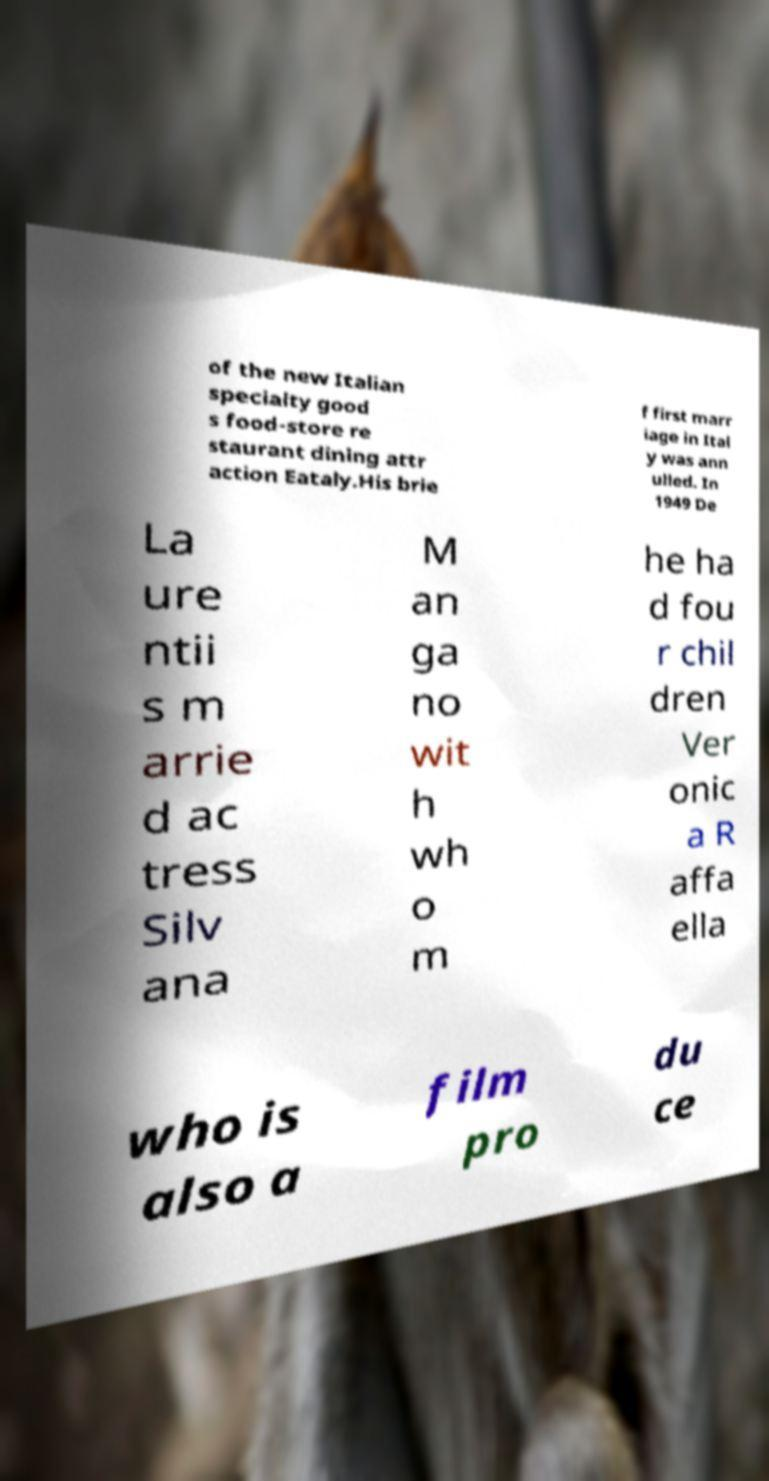What messages or text are displayed in this image? I need them in a readable, typed format. of the new Italian specialty good s food-store re staurant dining attr action Eataly.His brie f first marr iage in Ital y was ann ulled. In 1949 De La ure ntii s m arrie d ac tress Silv ana M an ga no wit h wh o m he ha d fou r chil dren Ver onic a R affa ella who is also a film pro du ce 